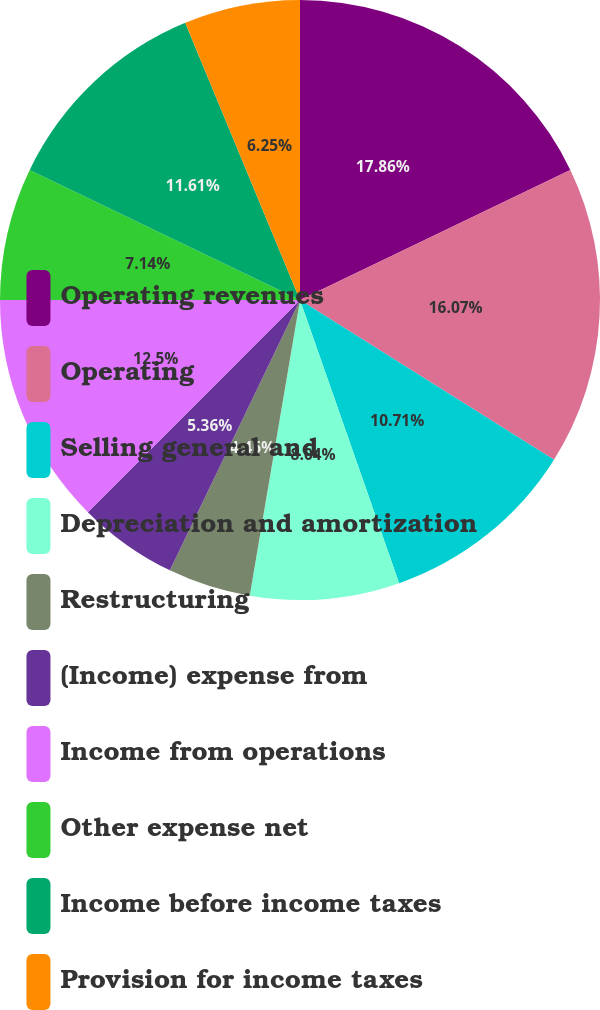Convert chart to OTSL. <chart><loc_0><loc_0><loc_500><loc_500><pie_chart><fcel>Operating revenues<fcel>Operating<fcel>Selling general and<fcel>Depreciation and amortization<fcel>Restructuring<fcel>(Income) expense from<fcel>Income from operations<fcel>Other expense net<fcel>Income before income taxes<fcel>Provision for income taxes<nl><fcel>17.86%<fcel>16.07%<fcel>10.71%<fcel>8.04%<fcel>4.46%<fcel>5.36%<fcel>12.5%<fcel>7.14%<fcel>11.61%<fcel>6.25%<nl></chart> 